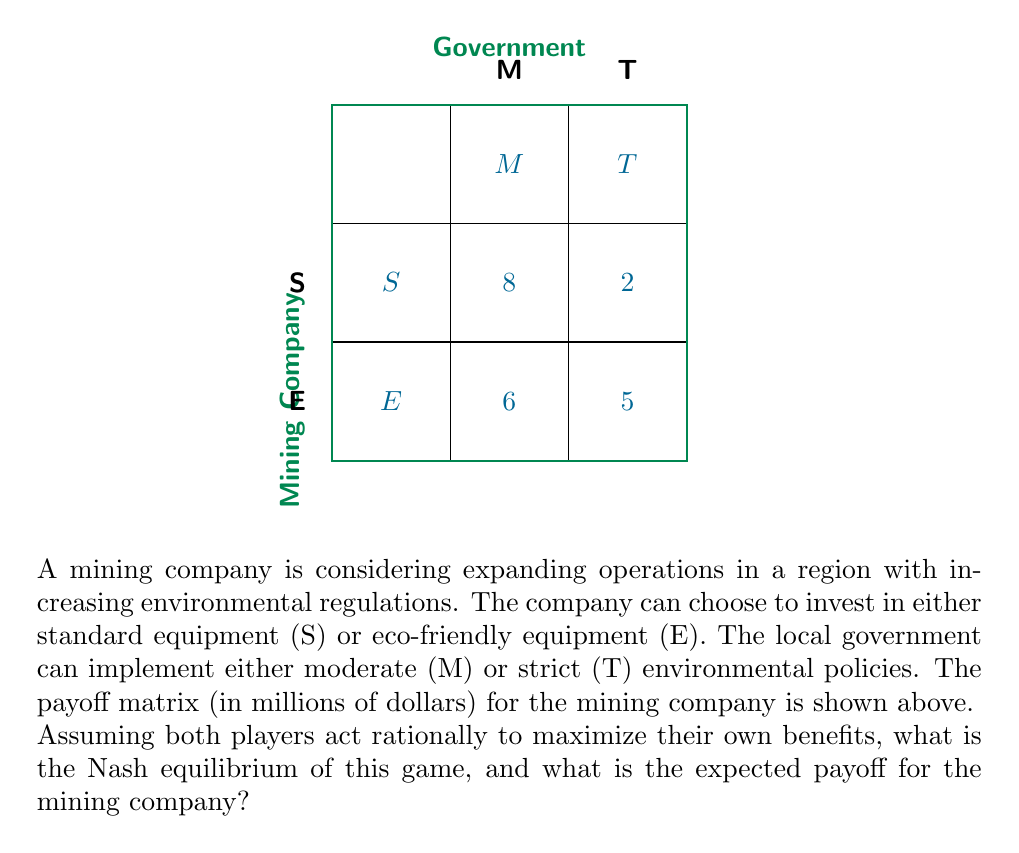Help me with this question. To solve this game theory problem, we need to follow these steps:

1) Identify the dominant strategies for each player:

   For the Mining Company:
   - If Government chooses M: S (8) > E (6)
   - If Government chooses T: E (5) > S (2)
   
   There is no dominant strategy for the Mining Company.

   For the Government:
   - If Mining Company chooses S: T (2) < M (8)
   - If Mining Company chooses E: T (5) < M (6)
   
   The dominant strategy for the Government is M.

2) Since the Government has a dominant strategy (M), we can eliminate the T column:

   [asy]
   unitsize(1cm);
   defaultpen(fontsize(10pt));
   
   draw((0,0)--(3,0)--(3,-4)--(0,-4)--cycle);
   draw((0,-2)--(3,-2));
   
   label("M", (1.5,0.3));
   
   label("S", (-0.3,-1));
   label("E", (-0.3,-3));
   
   label("8", (1.5,-1));
   label("6", (1.5,-3));
   [/asy]

3) Now, the Mining Company will choose S (8) over E (6) when the Government plays M.

4) Therefore, the Nash equilibrium is (S, M), where the Mining Company chooses Standard equipment (S) and the Government implements Moderate policies (M).

5) The expected payoff for the mining company in this Nash equilibrium is 8 million dollars.
Answer: Nash equilibrium: (S, M); Expected payoff: $8 million 